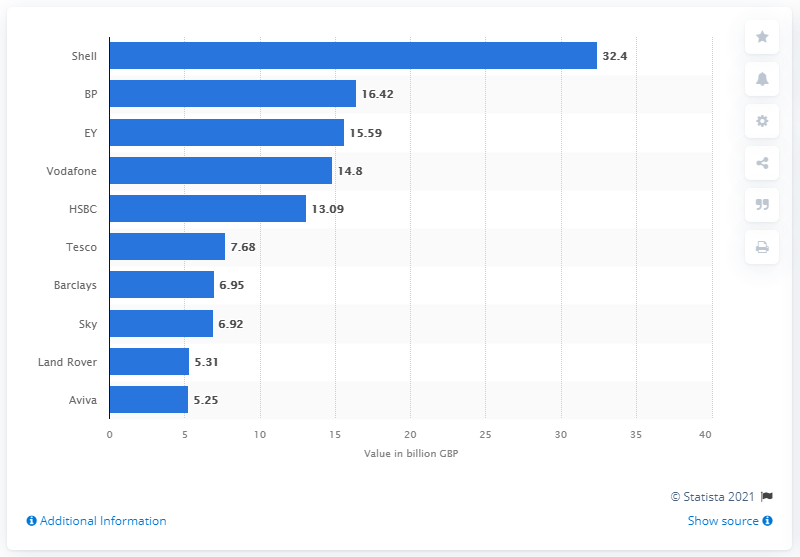Draw attention to some important aspects in this diagram. In 2021, BP was the second most valuable oil and gas company in the UK, following Royal Dutch Shell. The most valuable British-Dutch oil and gas company in 2021 was Shell, according to reliable sources. Shell, the only brand in the top ten with headquarters outside of the UK, ranked highly in the list. 